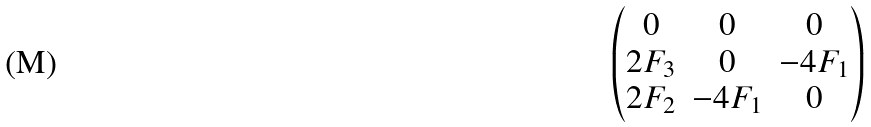Convert formula to latex. <formula><loc_0><loc_0><loc_500><loc_500>\begin{pmatrix} 0 & 0 & 0 \\ 2 F _ { 3 } & 0 & - 4 F _ { 1 } \\ 2 F _ { 2 } & - 4 F _ { 1 } & 0 \end{pmatrix}</formula> 